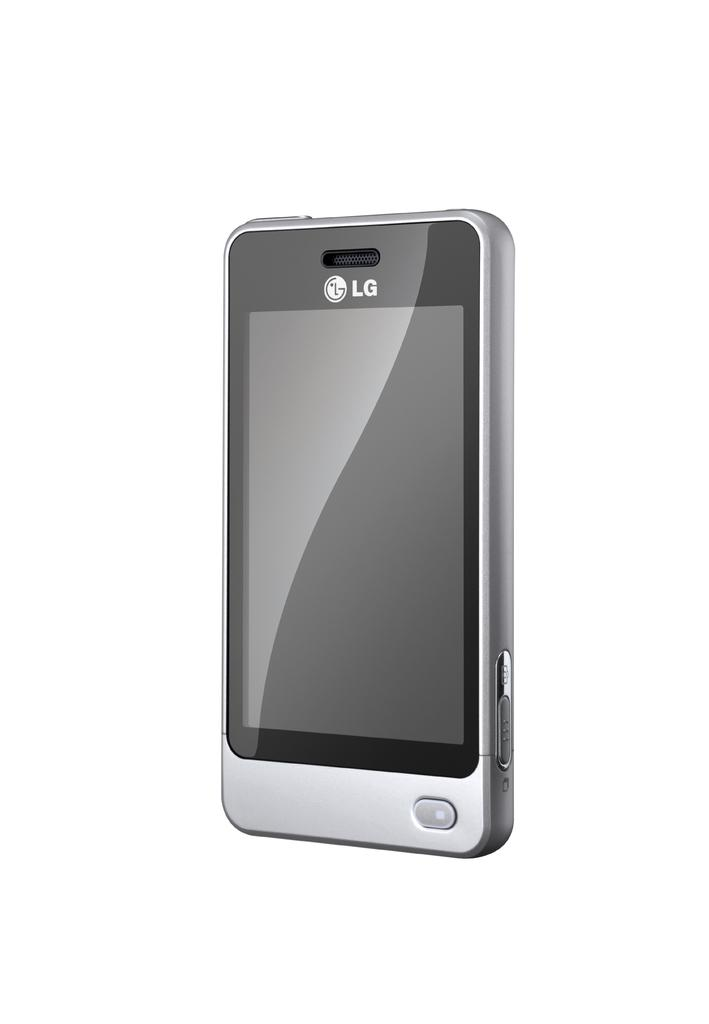Provide a one-sentence caption for the provided image. An LG smartphone is displayed surrounded by a white background. 